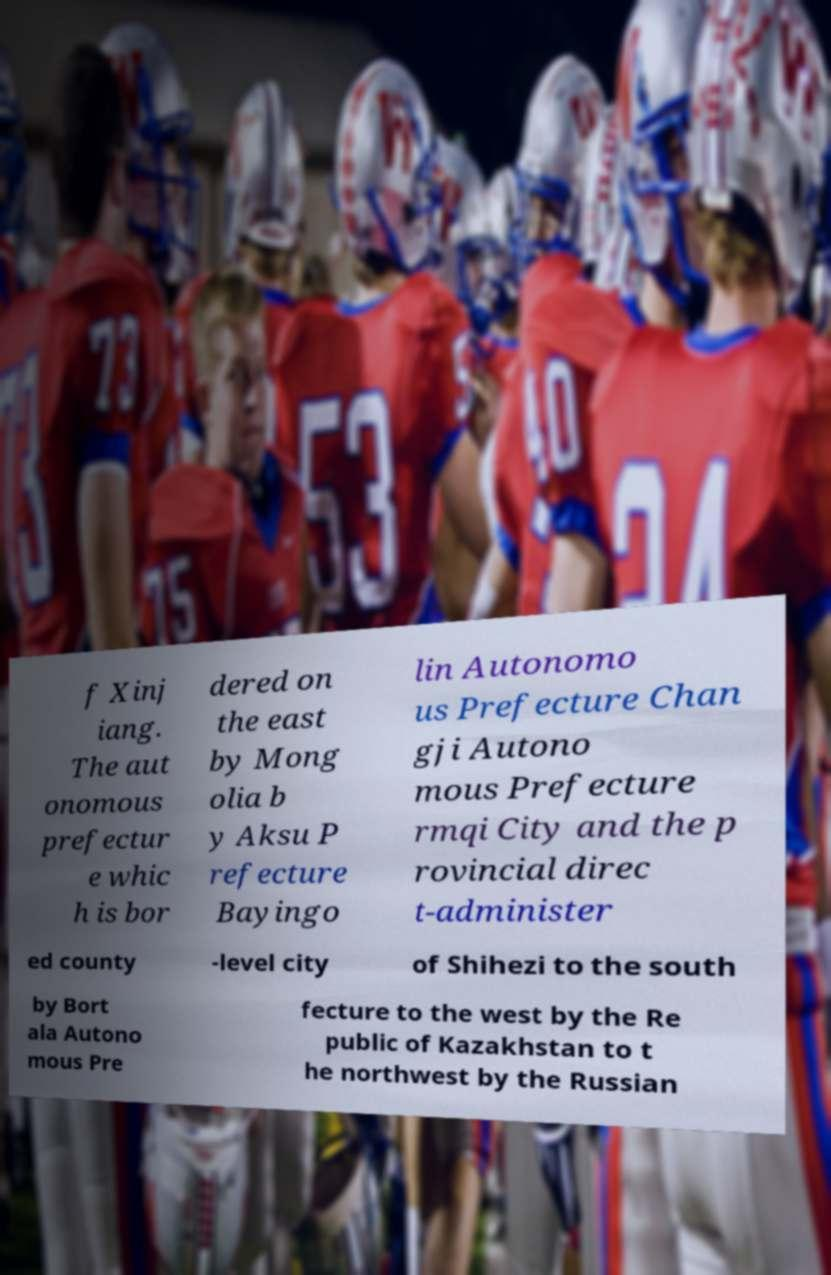Can you accurately transcribe the text from the provided image for me? f Xinj iang. The aut onomous prefectur e whic h is bor dered on the east by Mong olia b y Aksu P refecture Bayingo lin Autonomo us Prefecture Chan gji Autono mous Prefecture rmqi City and the p rovincial direc t-administer ed county -level city of Shihezi to the south by Bort ala Autono mous Pre fecture to the west by the Re public of Kazakhstan to t he northwest by the Russian 